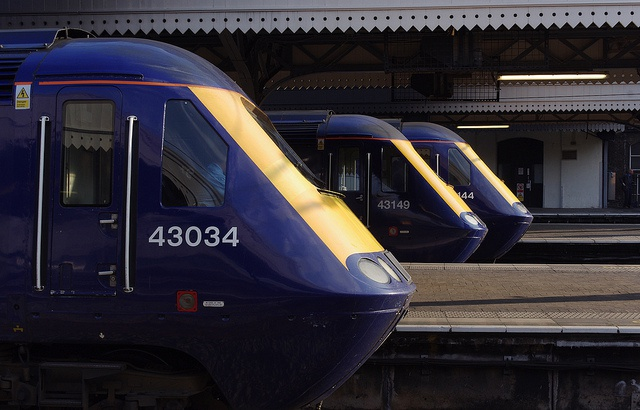Describe the objects in this image and their specific colors. I can see train in black, navy, gray, and khaki tones, people in black, navy, darkblue, and blue tones, and people in black, gray, and brown tones in this image. 